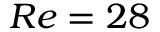<formula> <loc_0><loc_0><loc_500><loc_500>R e = 2 8</formula> 